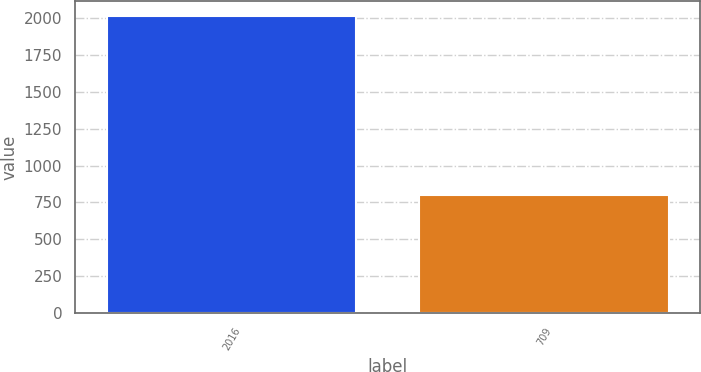Convert chart. <chart><loc_0><loc_0><loc_500><loc_500><bar_chart><fcel>2016<fcel>709<nl><fcel>2014<fcel>800<nl></chart> 